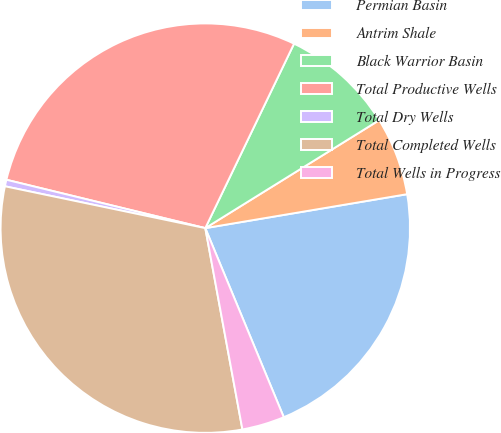<chart> <loc_0><loc_0><loc_500><loc_500><pie_chart><fcel>Permian Basin<fcel>Antrim Shale<fcel>Black Warrior Basin<fcel>Total Productive Wells<fcel>Total Dry Wells<fcel>Total Completed Wells<fcel>Total Wells in Progress<nl><fcel>21.39%<fcel>6.19%<fcel>9.02%<fcel>28.34%<fcel>0.52%<fcel>31.18%<fcel>3.36%<nl></chart> 